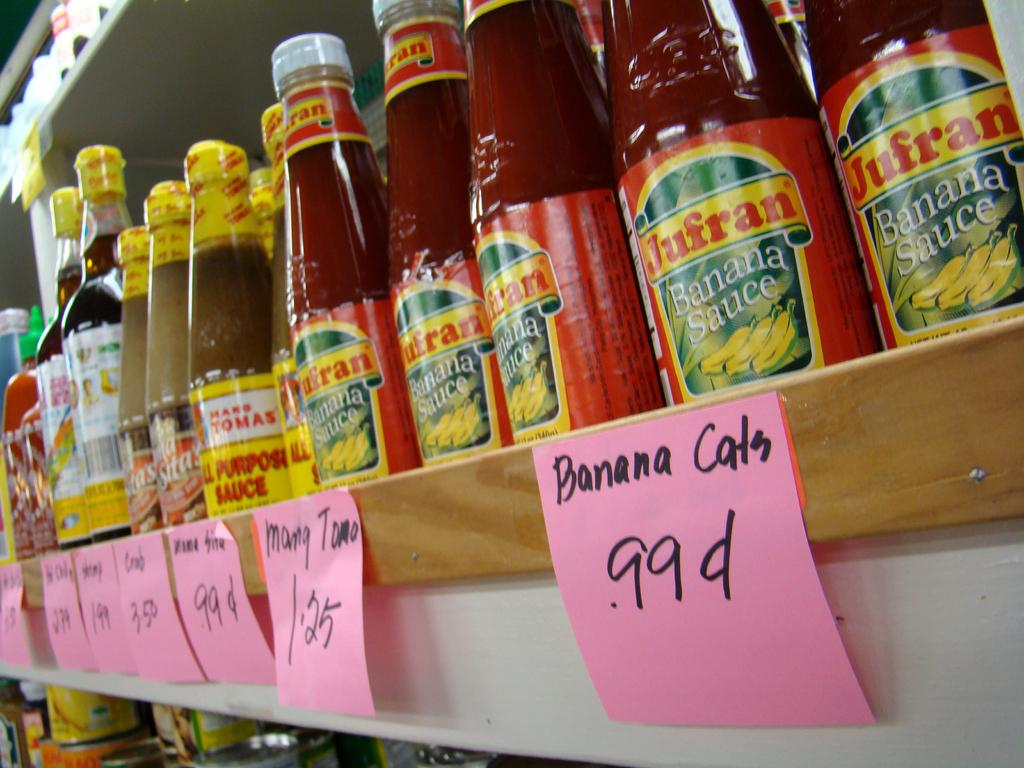<image>
Render a clear and concise summary of the photo. A shelf filled with Jufran Banana Sauce with pink post its with he words Banana cats .99 cents. 